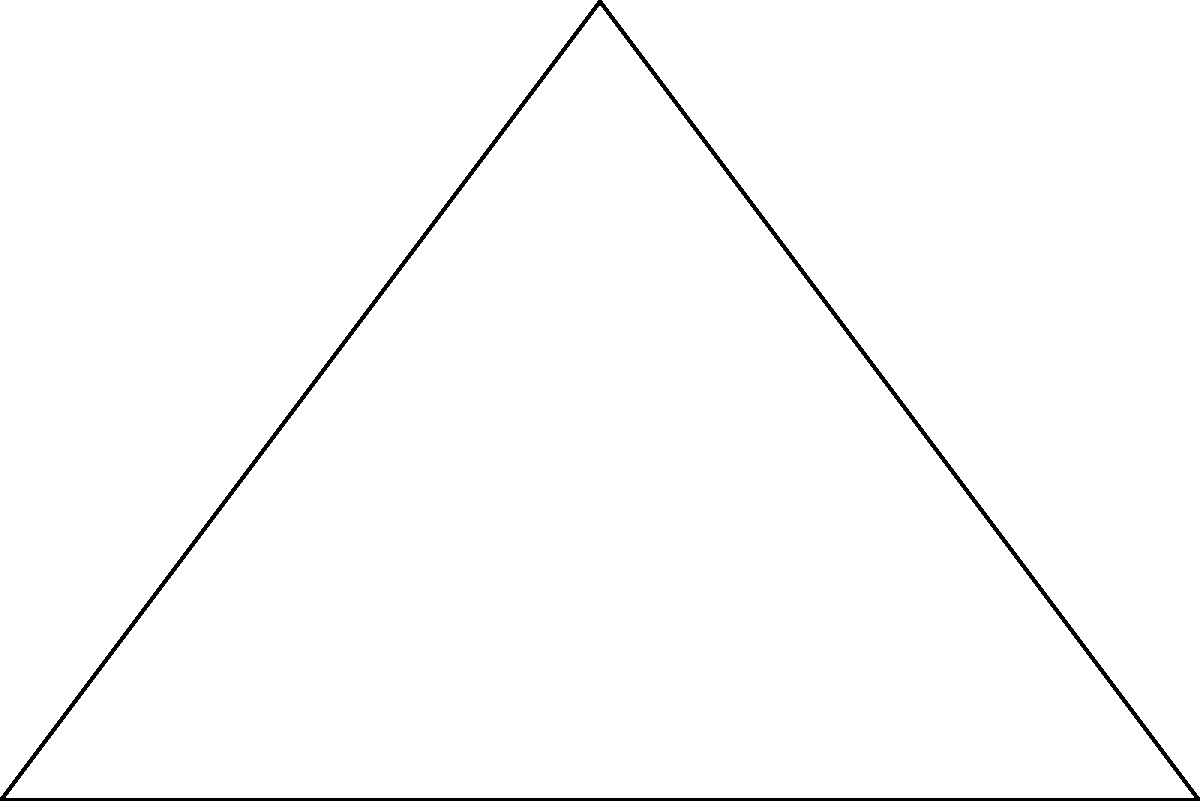A new radio station in Sindh needs to be built on a triangular plot of land. The plot has a right angle at point A, with sides AC measuring 4 km and AB measuring 3 km. What is the area of this triangular plot in square kilometers? To calculate the area of the triangular plot, we can use the formula for the area of a right-angled triangle:

$$\text{Area} = \frac{1}{2} \times \text{base} \times \text{height}$$

Given:
- AC (height) = 4 km
- AB (base) = 3 km

Step 1: Substitute the values into the formula:
$$\text{Area} = \frac{1}{2} \times 3 \text{ km} \times 4 \text{ km}$$

Step 2: Multiply the numbers:
$$\text{Area} = \frac{1}{2} \times 12 \text{ km}^2$$

Step 3: Calculate the final result:
$$\text{Area} = 6 \text{ km}^2$$

Therefore, the area of the triangular plot for the new radio station is 6 square kilometers.
Answer: 6 km² 